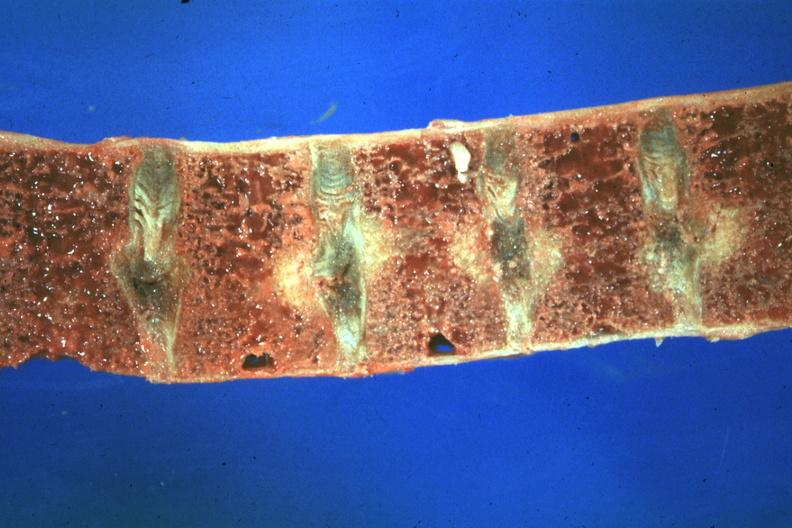what is present?
Answer the question using a single word or phrase. Joints 